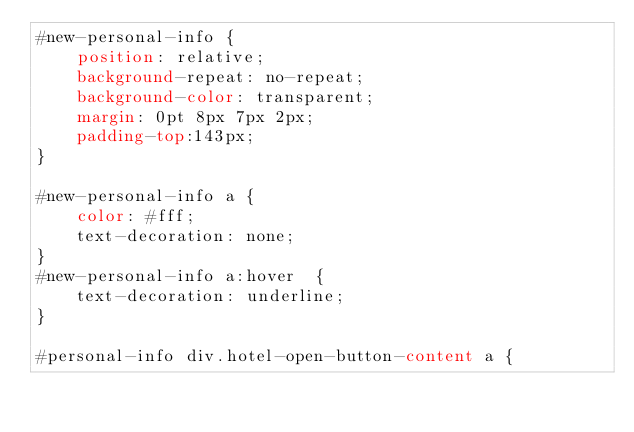Convert code to text. <code><loc_0><loc_0><loc_500><loc_500><_CSS_>#new-personal-info {
	position: relative;
	background-repeat: no-repeat;
	background-color: transparent;
	margin: 0pt 8px 7px 2px;
	padding-top:143px;	
}

#new-personal-info a {
	color: #fff;
	text-decoration: none;	
}
#new-personal-info a:hover  {
	text-decoration: underline;
}

#personal-info div.hotel-open-button-content a {</code> 